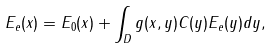Convert formula to latex. <formula><loc_0><loc_0><loc_500><loc_500>E _ { e } ( x ) = E _ { 0 } ( x ) + \int _ { D } g ( x , y ) C ( y ) E _ { e } ( y ) d y ,</formula> 